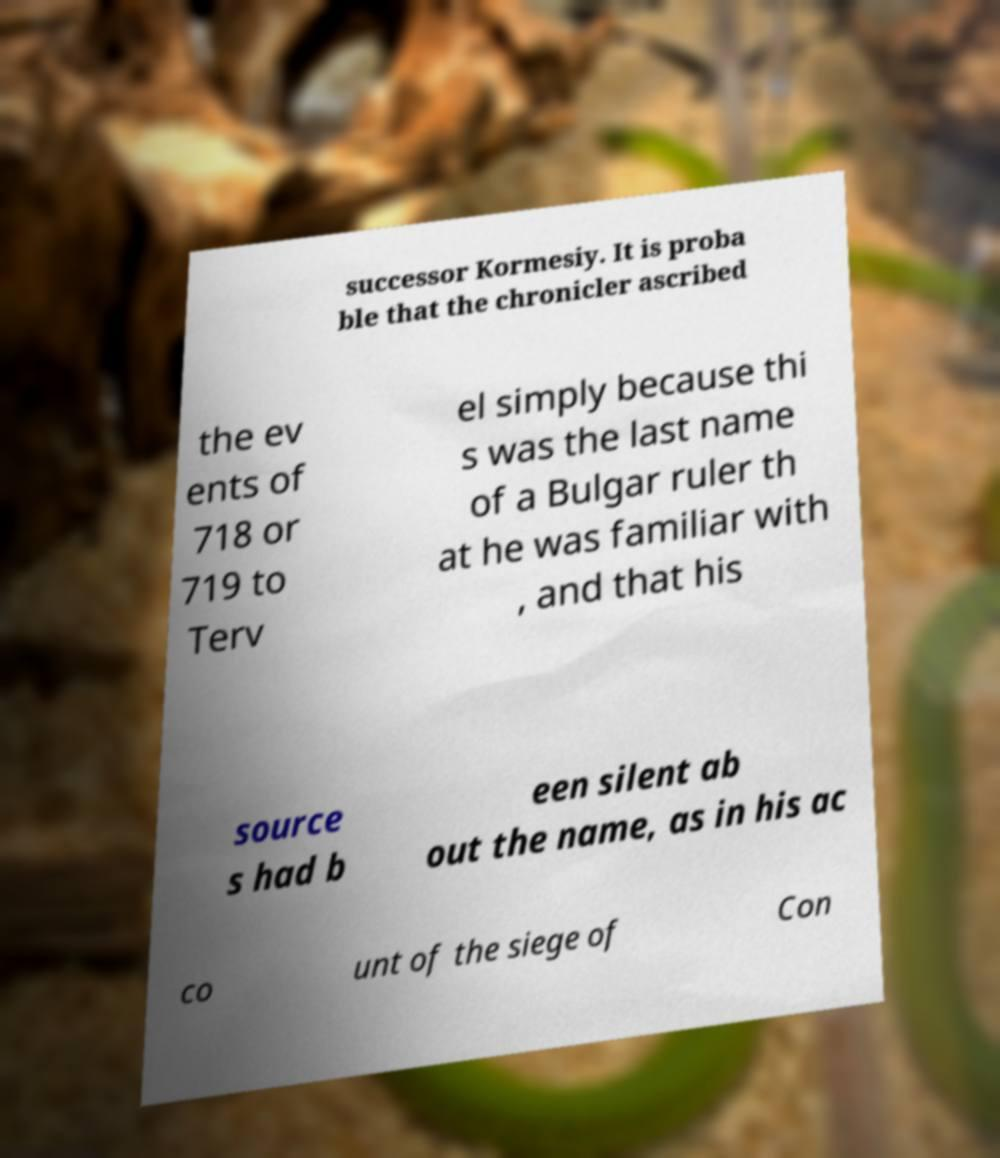Please identify and transcribe the text found in this image. successor Kormesiy. It is proba ble that the chronicler ascribed the ev ents of 718 or 719 to Terv el simply because thi s was the last name of a Bulgar ruler th at he was familiar with , and that his source s had b een silent ab out the name, as in his ac co unt of the siege of Con 